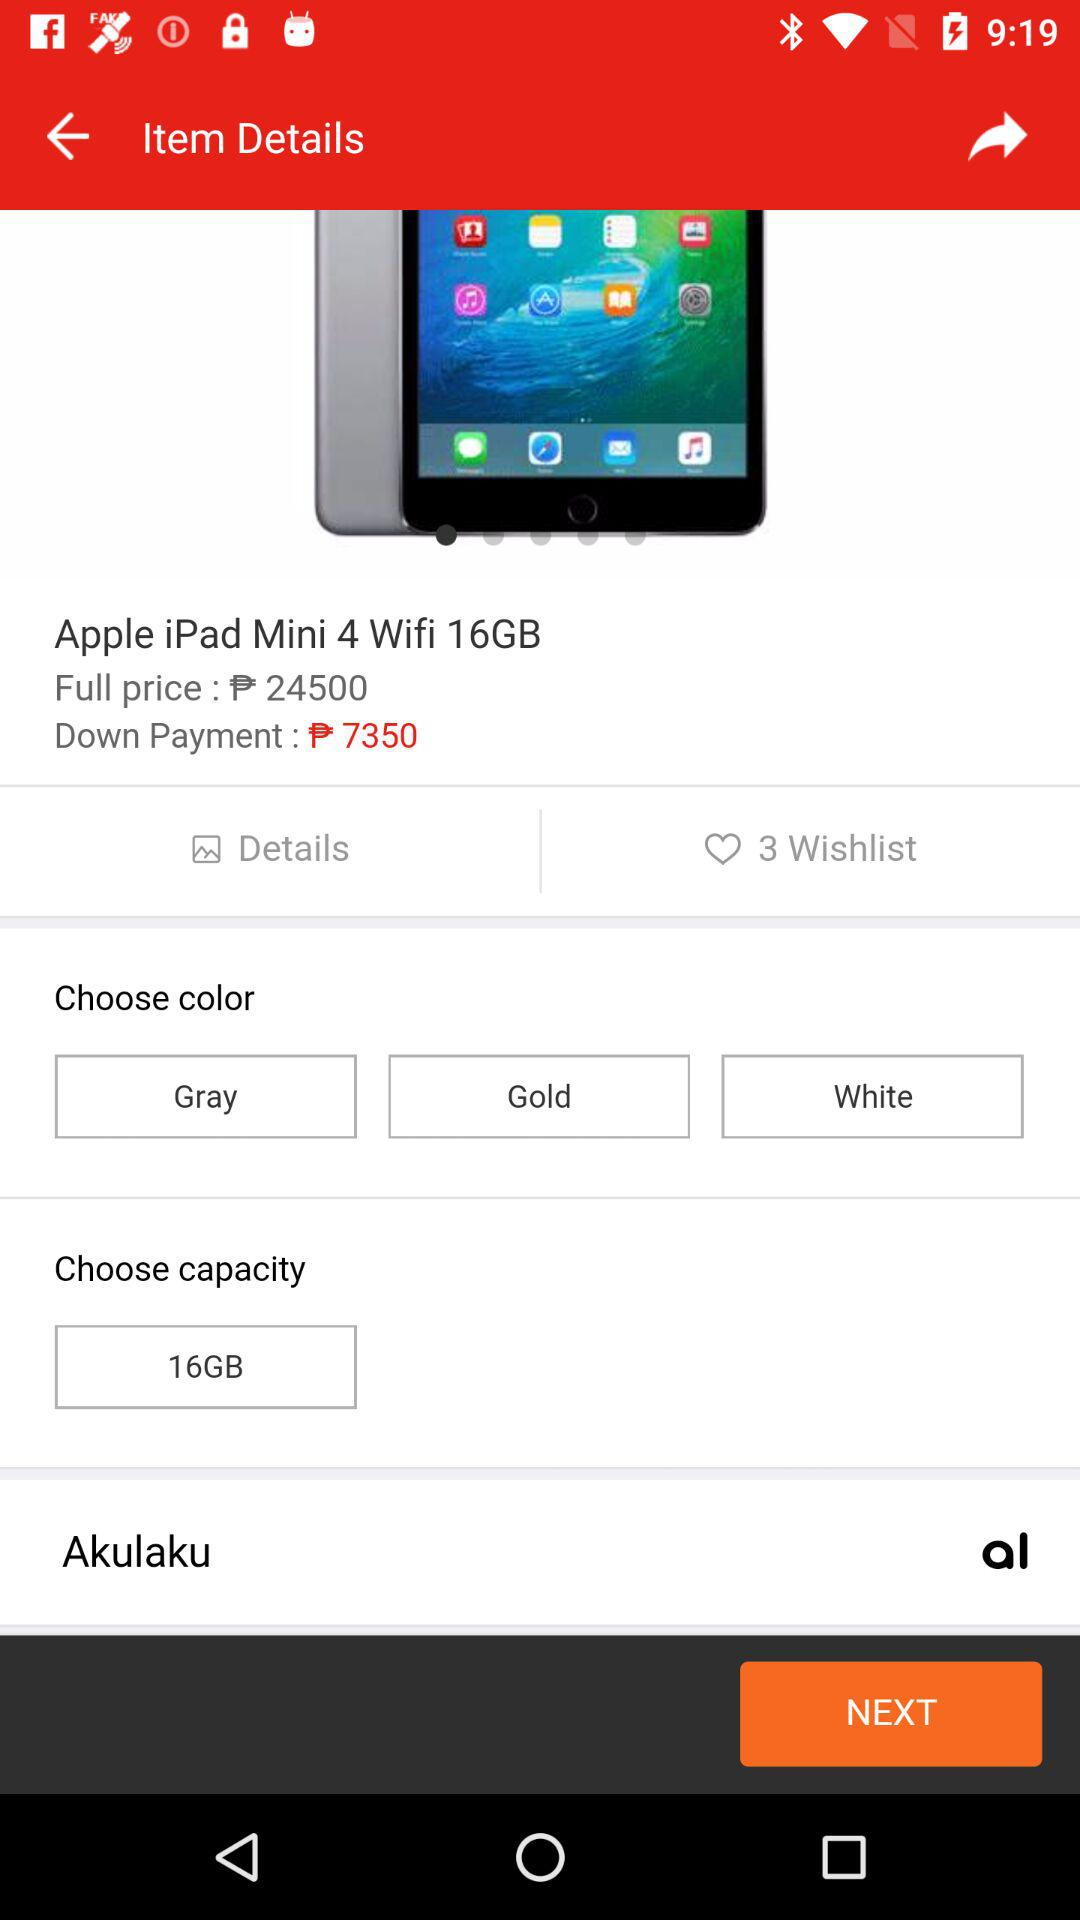How much is the down payment? The down payment is ₱7350. 